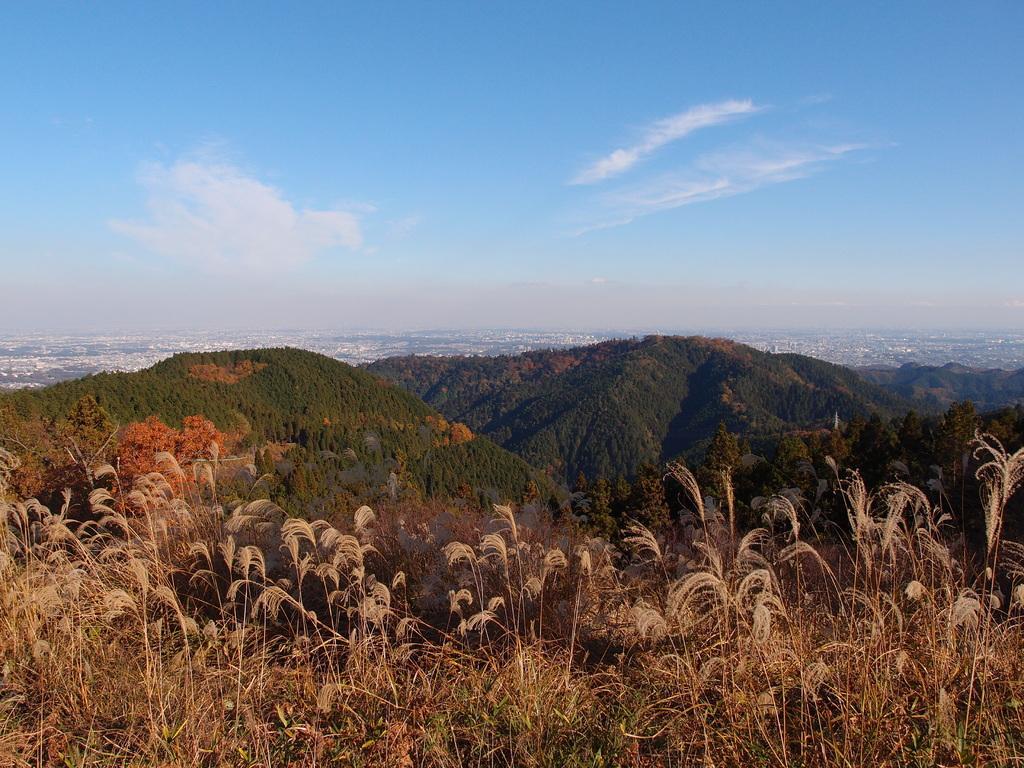Please provide a concise description of this image. At the bottom we can see grass and trees on the mountains. In the background there are trees,buildings and clouds in the sky. 